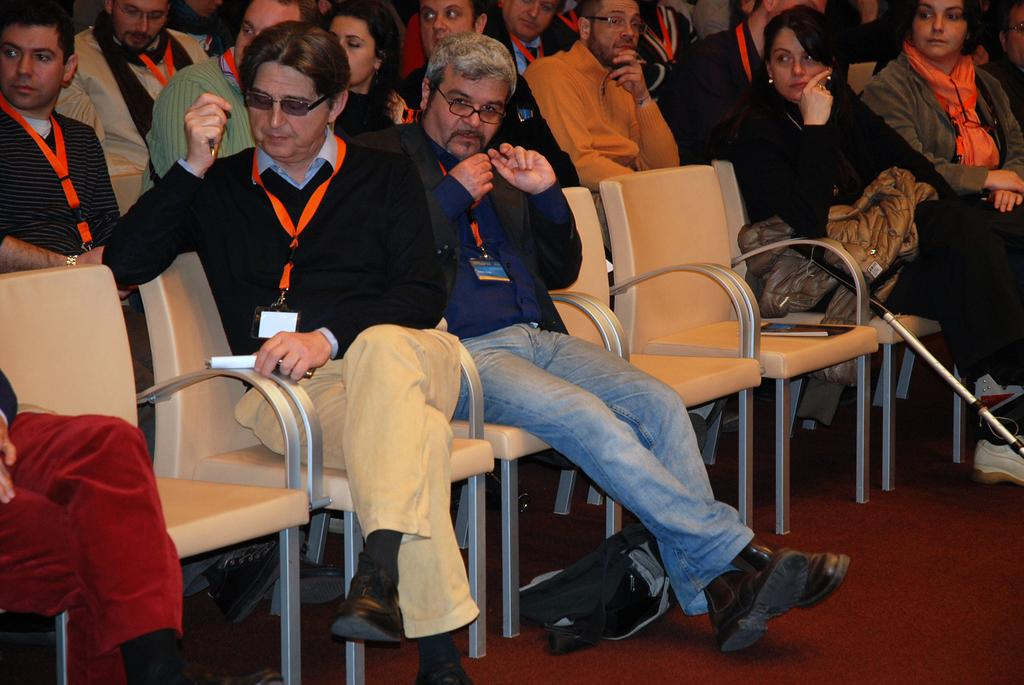How many people are in the image? There are a lot of people in the image. What are the people doing in the image? The people are sitting on chairs. What type of art can be seen on the chairs in the image? There is no art visible on the chairs in the image; the chairs are simply occupied by people. How do the people maintain their balance while sitting on the chairs in the image? The people do not need to maintain their balance in the image, as they are already sitting on the chairs. 